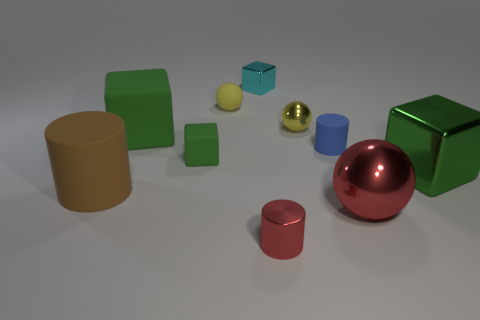There is a tiny sphere to the right of the yellow rubber thing; does it have the same color as the tiny metallic object that is on the left side of the small metallic cylinder?
Provide a succinct answer. No. What shape is the large green rubber thing?
Your answer should be very brief. Cube. Is the number of small metal blocks in front of the small cyan shiny object greater than the number of spheres?
Offer a terse response. No. There is a green thing to the right of the small green matte cube; what is its shape?
Provide a short and direct response. Cube. What number of other things are the same shape as the big green rubber object?
Your answer should be compact. 3. Does the small cylinder that is behind the tiny red cylinder have the same material as the red cylinder?
Give a very brief answer. No. Are there an equal number of small yellow metal balls to the left of the cyan cube and cubes that are on the left side of the small yellow metal thing?
Keep it short and to the point. No. What size is the metallic thing in front of the large metal sphere?
Offer a very short reply. Small. Are there any cubes that have the same material as the blue cylinder?
Your answer should be compact. Yes. Do the small shiny cylinder in front of the tiny green cube and the big metallic ball have the same color?
Your answer should be very brief. Yes. 